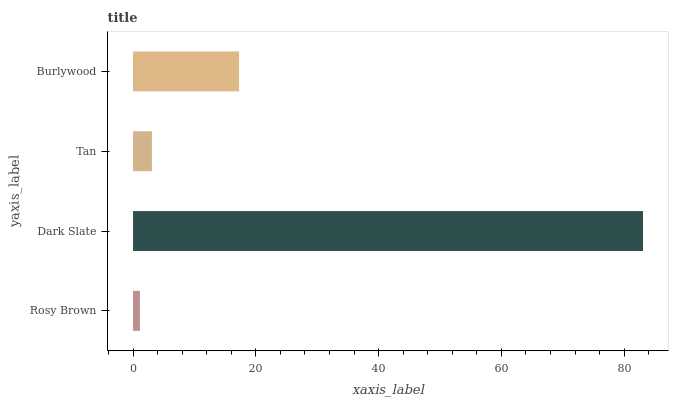Is Rosy Brown the minimum?
Answer yes or no. Yes. Is Dark Slate the maximum?
Answer yes or no. Yes. Is Tan the minimum?
Answer yes or no. No. Is Tan the maximum?
Answer yes or no. No. Is Dark Slate greater than Tan?
Answer yes or no. Yes. Is Tan less than Dark Slate?
Answer yes or no. Yes. Is Tan greater than Dark Slate?
Answer yes or no. No. Is Dark Slate less than Tan?
Answer yes or no. No. Is Burlywood the high median?
Answer yes or no. Yes. Is Tan the low median?
Answer yes or no. Yes. Is Tan the high median?
Answer yes or no. No. Is Dark Slate the low median?
Answer yes or no. No. 